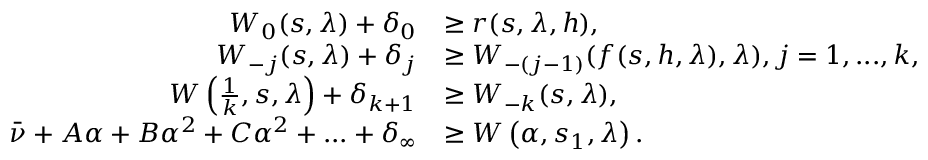<formula> <loc_0><loc_0><loc_500><loc_500>\begin{array} { r l } { W _ { 0 } ( s , \lambda ) + \delta _ { 0 } } & { \geq r ( s , \lambda , h ) , } \\ { W _ { - j } ( s , \lambda ) + \delta _ { j } } & { \geq W _ { - ( j - 1 ) } ( f ( s , h , \lambda ) , \lambda ) , j = 1 , \dots , k , } \\ { W \left ( \frac { 1 } { k } , s , \lambda \right ) + \delta _ { k + 1 } } & { \geq W _ { - k } ( s , \lambda ) , } \\ { \bar { \nu } + A \alpha + B \alpha ^ { 2 } + C \alpha ^ { 2 } + \dots + \delta _ { \infty } } & { \geq W \left ( \alpha , s _ { 1 } , \lambda \right ) . } \end{array}</formula> 